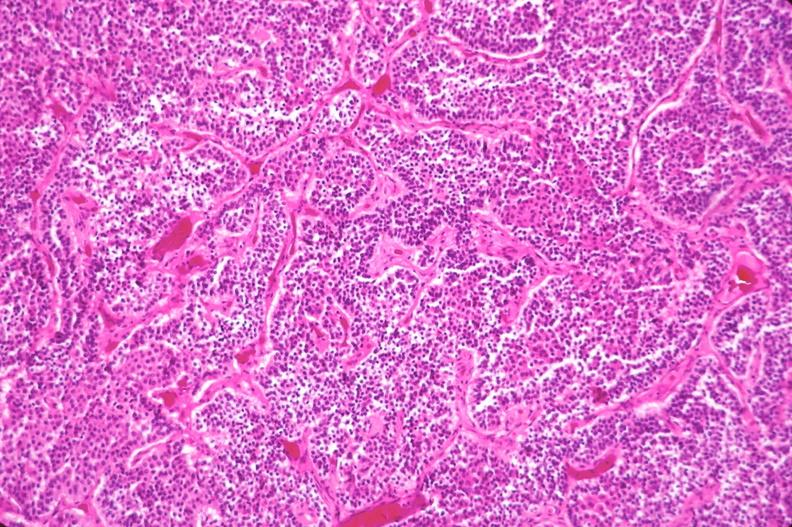what is present?
Answer the question using a single word or phrase. Endocrine 